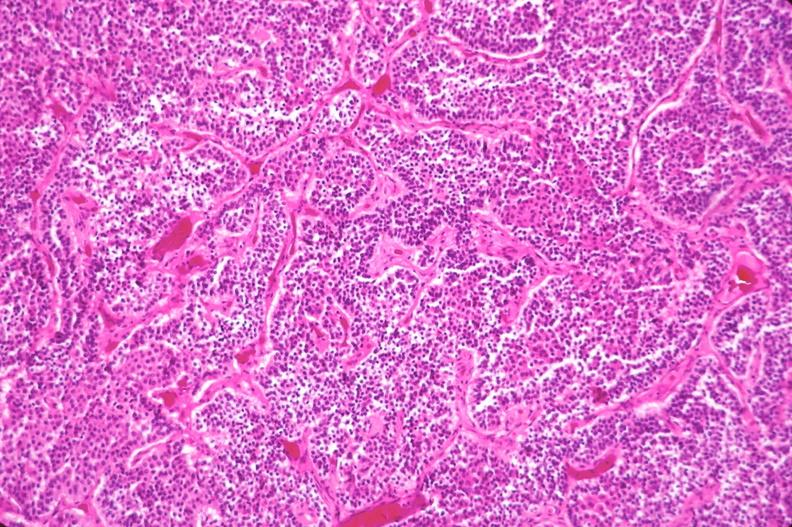what is present?
Answer the question using a single word or phrase. Endocrine 